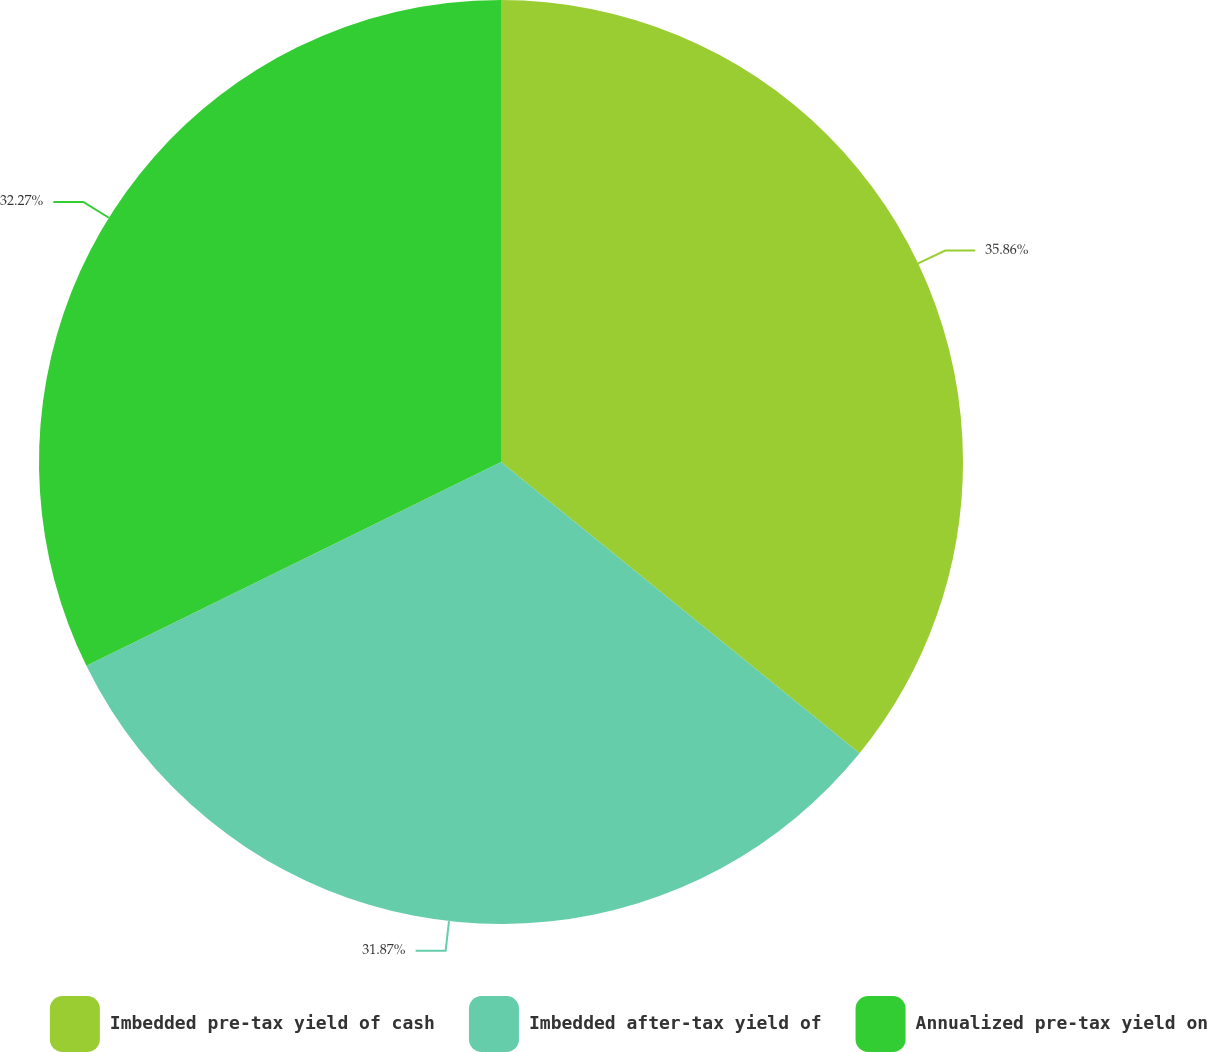Convert chart. <chart><loc_0><loc_0><loc_500><loc_500><pie_chart><fcel>Imbedded pre-tax yield of cash<fcel>Imbedded after-tax yield of<fcel>Annualized pre-tax yield on<nl><fcel>35.86%<fcel>31.87%<fcel>32.27%<nl></chart> 